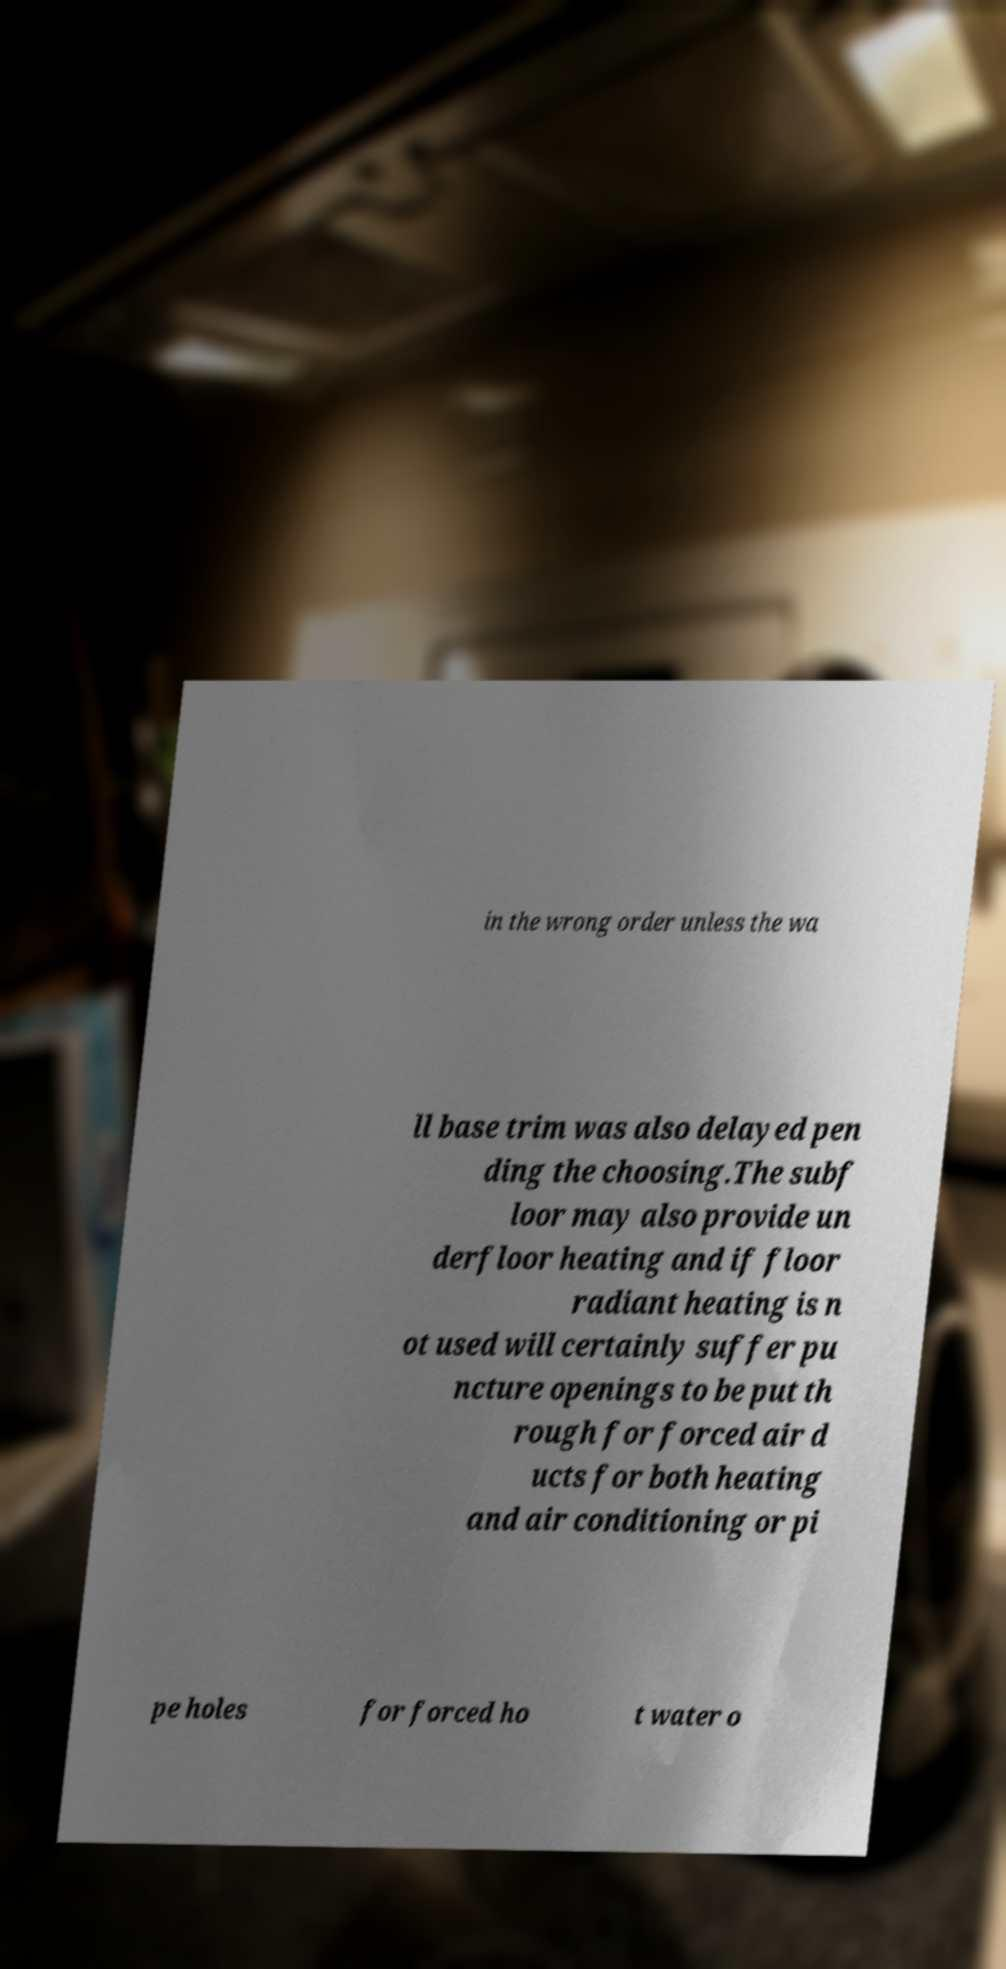What messages or text are displayed in this image? I need them in a readable, typed format. in the wrong order unless the wa ll base trim was also delayed pen ding the choosing.The subf loor may also provide un derfloor heating and if floor radiant heating is n ot used will certainly suffer pu ncture openings to be put th rough for forced air d ucts for both heating and air conditioning or pi pe holes for forced ho t water o 